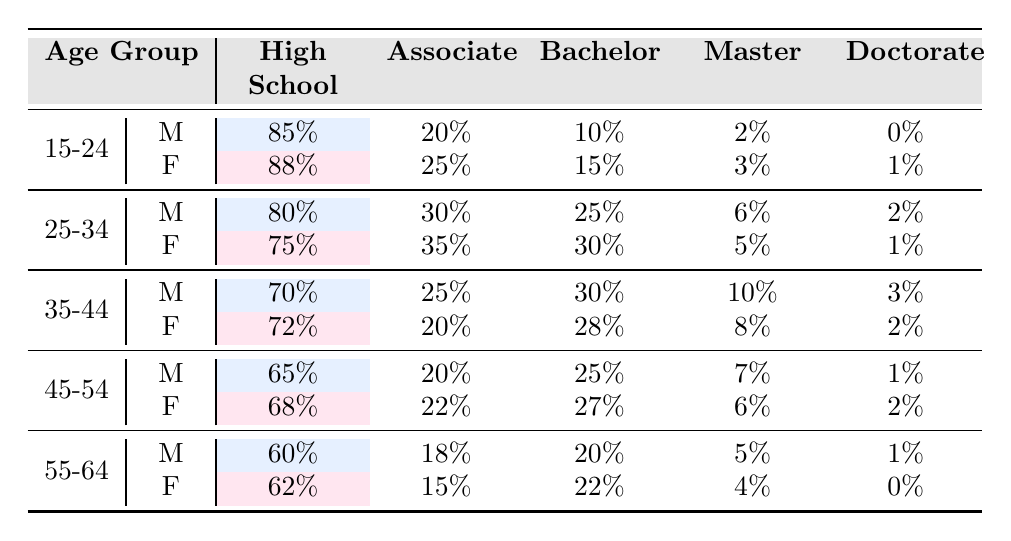What percentage of females aged 15-24 have a Bachelor's degree? In the table under the age group 15-24 and the gender Female, the value for Bachelor's degree is 15%.
Answer: 15% Which age group shows the highest percentage of males with a Master’s degree? The age group 35-44 has the highest percentage of males with a Master’s degree, which is 10%.
Answer: 10% What is the difference in the percentage of males and females who have completed high school in the age group 45-54? For males aged 45-54, the percentage is 65%, and for females, it is 68%. The difference is 68 - 65 = 3%.
Answer: 3% What percentage of females aged 55-64 have either a Master's degree or a Doctorate? Females aged 55-64 have 4% with a Master's degree and 0% with a Doctorate, which totals 4%.
Answer: 4% In which age group do females have a higher percentage of Associate degrees compared to males? In the age group 25-34, females have 35% for Associate degrees compared to 30% for males.
Answer: 25-34 What is the combined percentage of Bachelor’s and Master’s degrees for males aged 45-54? Males aged 45-54 have 25% with a Bachelor’s degree and 7% with a Master’s degree. The combined percentage is 25 + 7 = 32%.
Answer: 32% Is it true that the percentage of females who have completed high school is higher than that of males in all age groups? The data shows that males have a higher percentage in the age group 55-64 (60%) compared to females (62%), making the statement false.
Answer: False What is the average percentage of Doctorate degrees across all age groups for males? The percentages for males are 0, 2, 3, 1, and 1, which totals to 7%. Dividing by the number of groups (5), the average is 7/5 = 1.4%.
Answer: 1.4% In the age group 35-44, what is the combined percentage of individuals who have either an Associate degree or a Bachelor’s degree for females? Females aged 35-44 have 20% with Associate degrees and 28% with Bachelor’s degrees, totaling 20 + 28 = 48%.
Answer: 48% Which age group has the lowest percentage of individuals with a Doctorate degree? The age group 15-24 has the lowest percentage of individuals with a Doctorate degree, with both males and females having 0% and 1%, respectively.
Answer: 15-24 